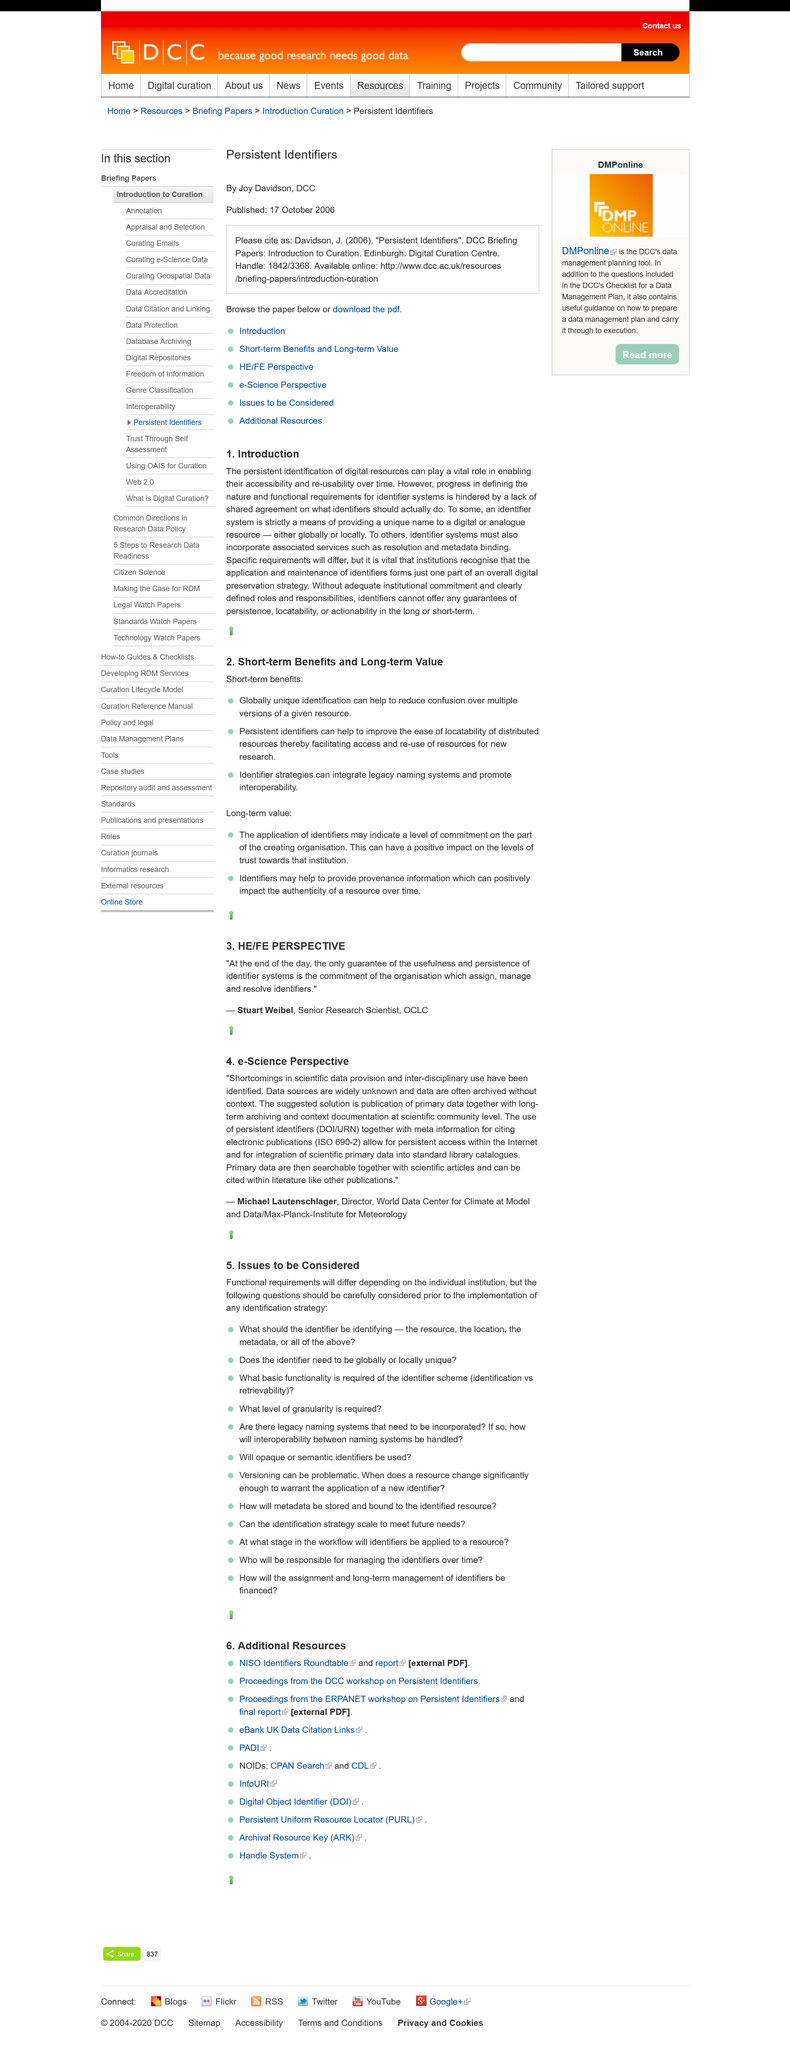Mention a couple of crucial points in this snapshot. Michael is a director at his company. According to the "Introduction", guarantees such as persistence, locatability, and actionability cannot be offered. Michael Lautenschlager is the author of the quote. The lack of agreement on the purpose and functional requirements of identifier systems hindered progress in defining their nature. Persistent identification of digital resources is essential for their accessibility and re-usability over time, playing a vital role in ensuring their long-term preservation and utility. 